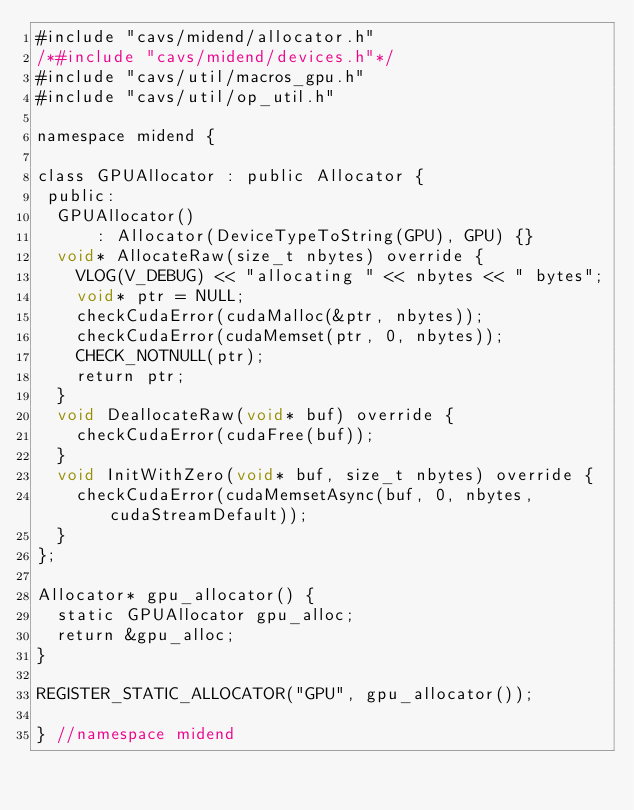<code> <loc_0><loc_0><loc_500><loc_500><_Cuda_>#include "cavs/midend/allocator.h"
/*#include "cavs/midend/devices.h"*/
#include "cavs/util/macros_gpu.h"
#include "cavs/util/op_util.h"

namespace midend {

class GPUAllocator : public Allocator {
 public:
  GPUAllocator() 
      : Allocator(DeviceTypeToString(GPU), GPU) {}    
  void* AllocateRaw(size_t nbytes) override {
    VLOG(V_DEBUG) << "allocating " << nbytes << " bytes";
    void* ptr = NULL;
    checkCudaError(cudaMalloc(&ptr, nbytes)); 
    checkCudaError(cudaMemset(ptr, 0, nbytes)); 
    CHECK_NOTNULL(ptr);
    return ptr;
  }
  void DeallocateRaw(void* buf) override {
    checkCudaError(cudaFree(buf));
  }
  void InitWithZero(void* buf, size_t nbytes) override {
    checkCudaError(cudaMemsetAsync(buf, 0, nbytes, cudaStreamDefault));
  }
};

Allocator* gpu_allocator() {
  static GPUAllocator gpu_alloc;
  return &gpu_alloc;
}

REGISTER_STATIC_ALLOCATOR("GPU", gpu_allocator());

} //namespace midend
</code> 